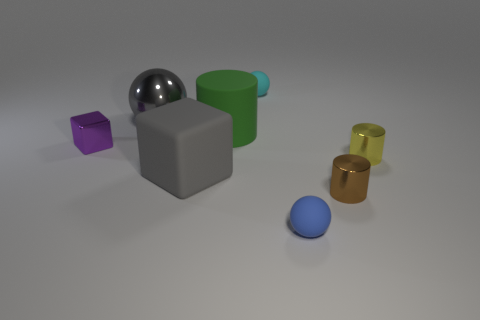How many blue things are either metallic cylinders or large rubber blocks?
Your answer should be compact. 0. Is the number of small objects right of the big gray metal ball less than the number of things that are behind the small blue thing?
Give a very brief answer. Yes. There is a brown metal thing; is it the same size as the matte sphere in front of the cyan thing?
Make the answer very short. Yes. What number of green rubber cylinders are the same size as the gray metal object?
Your answer should be very brief. 1. What number of small things are either brown rubber cubes or cyan things?
Your answer should be compact. 1. Is there a yellow cube?
Provide a succinct answer. No. Are there more cubes that are right of the purple cube than yellow cylinders in front of the gray rubber cube?
Give a very brief answer. Yes. There is a object in front of the small metal thing in front of the small yellow shiny cylinder; what is its color?
Provide a succinct answer. Blue. Is there a large cube that has the same color as the large ball?
Your response must be concise. Yes. What is the size of the sphere left of the tiny ball behind the small cylinder that is in front of the big rubber block?
Give a very brief answer. Large. 